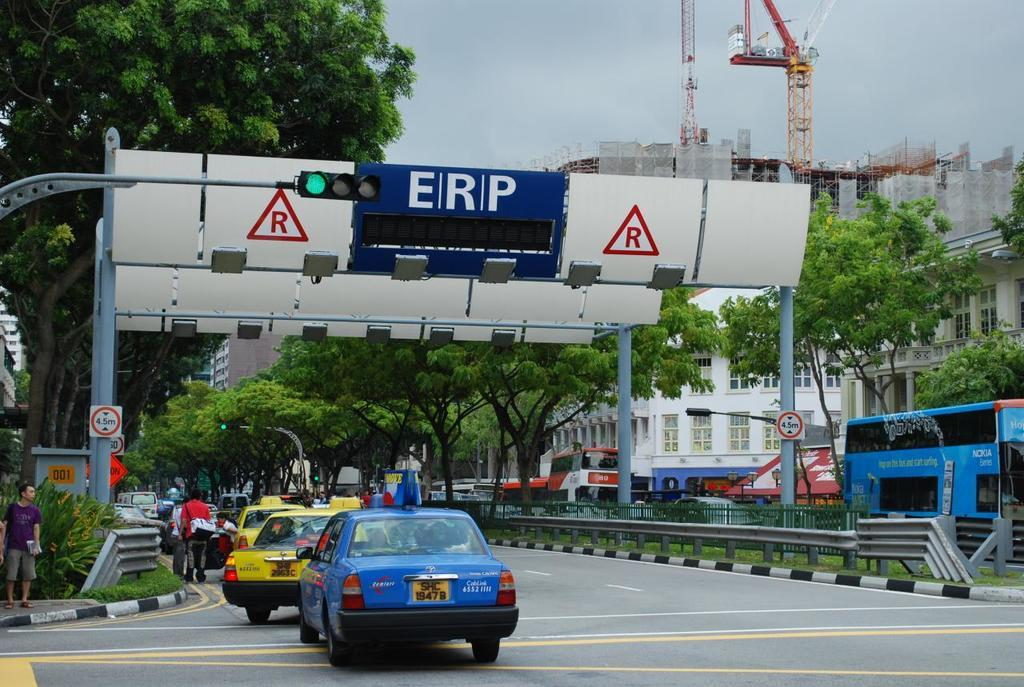<image>
Share a concise interpretation of the image provided. A white sign that is behind the stop light and says ERP. 